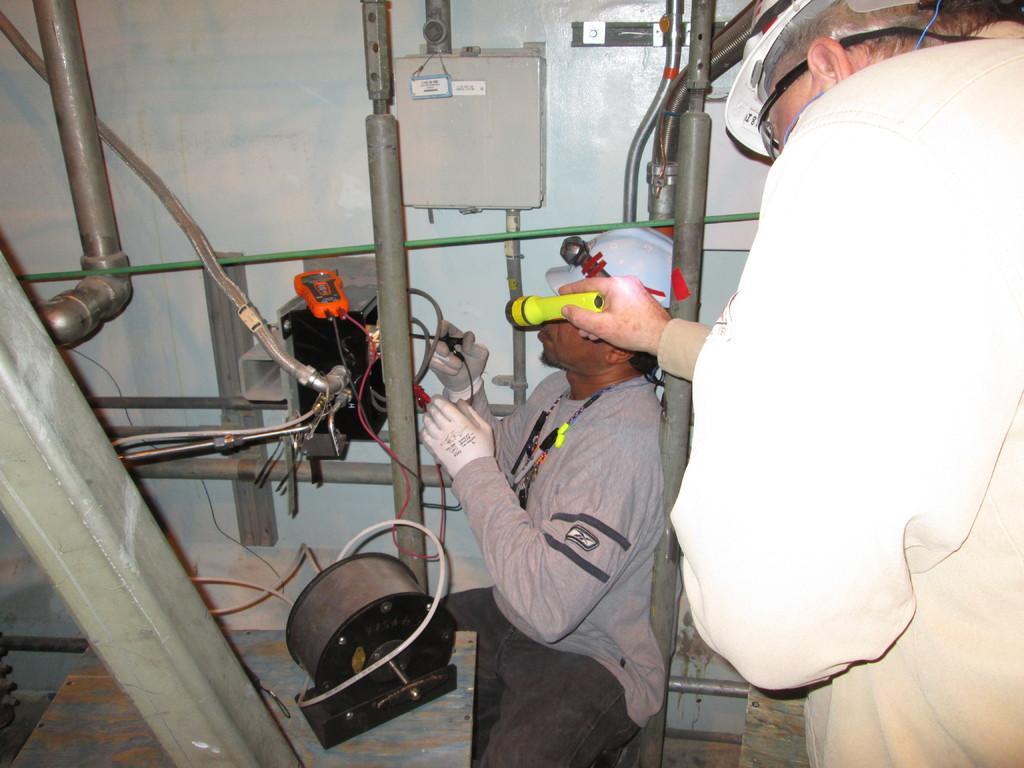Could you give a brief overview of what you see in this image? On the right side of the image there is a man with a helmet on his head and holding a torch in his hand. In front of him there is a person with a helmet on his head and holding tools. In front of that person there is a box with wires. In the background on the wall there is a board. And in the image there are many wires and also there is a pole. And also there is a machine. 